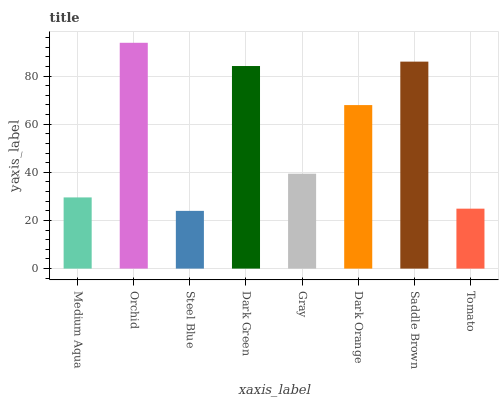Is Steel Blue the minimum?
Answer yes or no. Yes. Is Orchid the maximum?
Answer yes or no. Yes. Is Orchid the minimum?
Answer yes or no. No. Is Steel Blue the maximum?
Answer yes or no. No. Is Orchid greater than Steel Blue?
Answer yes or no. Yes. Is Steel Blue less than Orchid?
Answer yes or no. Yes. Is Steel Blue greater than Orchid?
Answer yes or no. No. Is Orchid less than Steel Blue?
Answer yes or no. No. Is Dark Orange the high median?
Answer yes or no. Yes. Is Gray the low median?
Answer yes or no. Yes. Is Gray the high median?
Answer yes or no. No. Is Dark Green the low median?
Answer yes or no. No. 